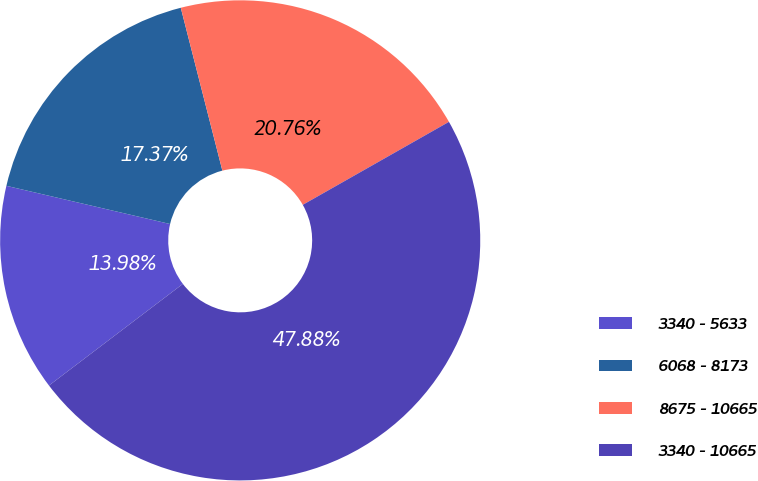Convert chart to OTSL. <chart><loc_0><loc_0><loc_500><loc_500><pie_chart><fcel>3340 - 5633<fcel>6068 - 8173<fcel>8675 - 10665<fcel>3340 - 10665<nl><fcel>13.98%<fcel>17.37%<fcel>20.76%<fcel>47.88%<nl></chart> 